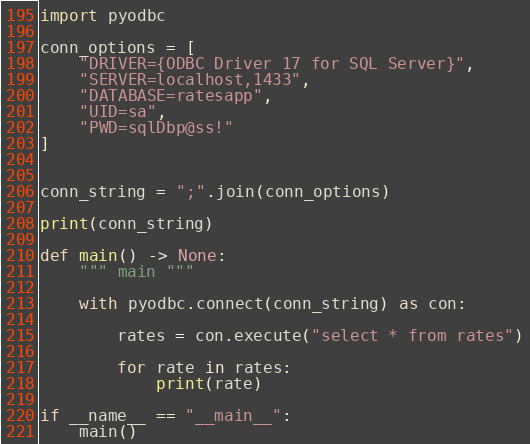Convert code to text. <code><loc_0><loc_0><loc_500><loc_500><_Python_>
import pyodbc

conn_options = [
    "DRIVER={ODBC Driver 17 for SQL Server}",
    "SERVER=localhost,1433",
    "DATABASE=ratesapp",
    "UID=sa",
    "PWD=sqlDbp@ss!"
]


conn_string = ";".join(conn_options)

print(conn_string)

def main() -> None:
    """ main """

    with pyodbc.connect(conn_string) as con:

        rates = con.execute("select * from rates")

        for rate in rates:
            print(rate)

if __name__ == "__main__":
    main()
</code> 